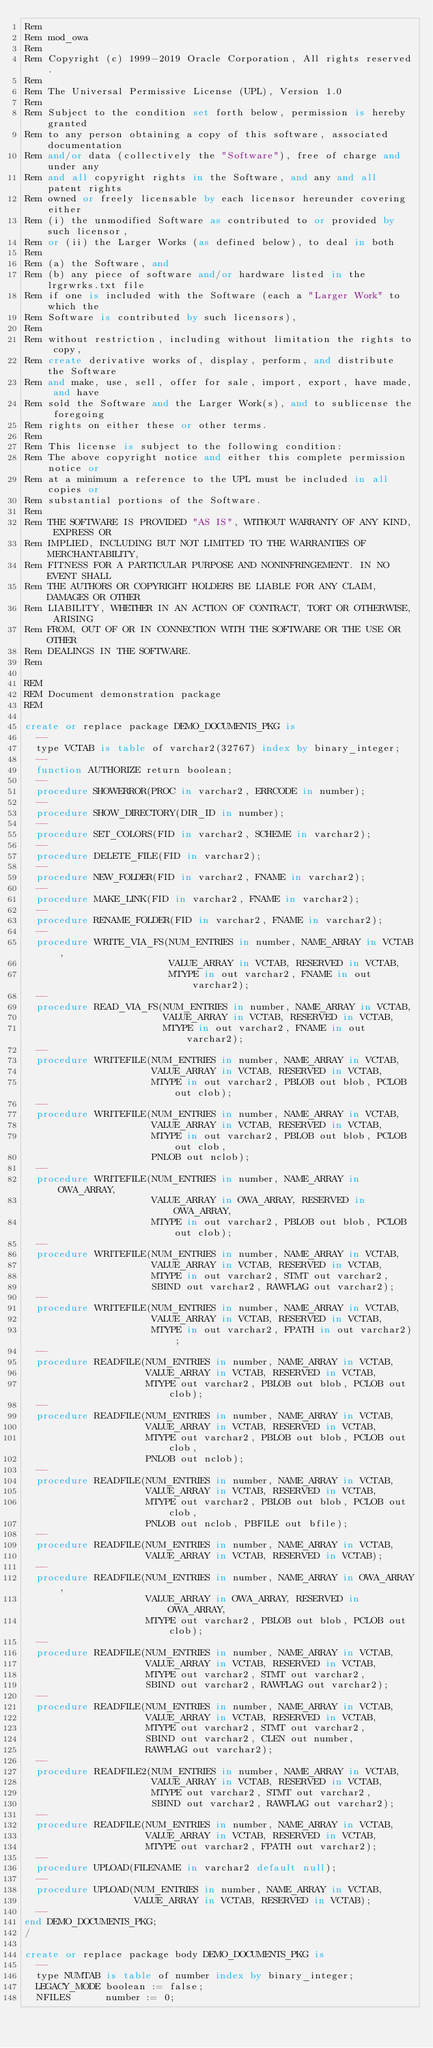Convert code to text. <code><loc_0><loc_0><loc_500><loc_500><_SQL_>Rem
Rem mod_owa
Rem
Rem Copyright (c) 1999-2019 Oracle Corporation, All rights reserved.
Rem
Rem The Universal Permissive License (UPL), Version 1.0
Rem
Rem Subject to the condition set forth below, permission is hereby granted
Rem to any person obtaining a copy of this software, associated documentation
Rem and/or data (collectively the "Software"), free of charge and under any
Rem and all copyright rights in the Software, and any and all patent rights
Rem owned or freely licensable by each licensor hereunder covering either
Rem (i) the unmodified Software as contributed to or provided by such licensor,
Rem or (ii) the Larger Works (as defined below), to deal in both
Rem 
Rem (a) the Software, and
Rem (b) any piece of software and/or hardware listed in the lrgrwrks.txt file
Rem if one is included with the Software (each a "Larger Work" to which the
Rem Software is contributed by such licensors),
Rem 
Rem without restriction, including without limitation the rights to copy,
Rem create derivative works of, display, perform, and distribute the Software
Rem and make, use, sell, offer for sale, import, export, have made, and have
Rem sold the Software and the Larger Work(s), and to sublicense the foregoing
Rem rights on either these or other terms.
Rem 
Rem This license is subject to the following condition:
Rem The above copyright notice and either this complete permission notice or
Rem at a minimum a reference to the UPL must be included in all copies or
Rem substantial portions of the Software.
Rem 
Rem THE SOFTWARE IS PROVIDED "AS IS", WITHOUT WARRANTY OF ANY KIND, EXPRESS OR
Rem IMPLIED, INCLUDING BUT NOT LIMITED TO THE WARRANTIES OF MERCHANTABILITY,
Rem FITNESS FOR A PARTICULAR PURPOSE AND NONINFRINGEMENT. IN NO EVENT SHALL
Rem THE AUTHORS OR COPYRIGHT HOLDERS BE LIABLE FOR ANY CLAIM, DAMAGES OR OTHER
Rem LIABILITY, WHETHER IN AN ACTION OF CONTRACT, TORT OR OTHERWISE, ARISING
Rem FROM, OUT OF OR IN CONNECTION WITH THE SOFTWARE OR THE USE OR OTHER
Rem DEALINGS IN THE SOFTWARE.
Rem

REM
REM Document demonstration package
REM

create or replace package DEMO_DOCUMENTS_PKG is
  --
  type VCTAB is table of varchar2(32767) index by binary_integer;
  --
  function AUTHORIZE return boolean;
  --
  procedure SHOWERROR(PROC in varchar2, ERRCODE in number);
  --
  procedure SHOW_DIRECTORY(DIR_ID in number);
  --
  procedure SET_COLORS(FID in varchar2, SCHEME in varchar2);
  --
  procedure DELETE_FILE(FID in varchar2);
  --
  procedure NEW_FOLDER(FID in varchar2, FNAME in varchar2);
  --
  procedure MAKE_LINK(FID in varchar2, FNAME in varchar2);
  --
  procedure RENAME_FOLDER(FID in varchar2, FNAME in varchar2);
  --
  procedure WRITE_VIA_FS(NUM_ENTRIES in number, NAME_ARRAY in VCTAB,
                         VALUE_ARRAY in VCTAB, RESERVED in VCTAB,
                         MTYPE in out varchar2, FNAME in out varchar2);
  --
  procedure READ_VIA_FS(NUM_ENTRIES in number, NAME_ARRAY in VCTAB,
                        VALUE_ARRAY in VCTAB, RESERVED in VCTAB,
                        MTYPE in out varchar2, FNAME in out varchar2);
  --
  procedure WRITEFILE(NUM_ENTRIES in number, NAME_ARRAY in VCTAB,
                      VALUE_ARRAY in VCTAB, RESERVED in VCTAB,
                      MTYPE in out varchar2, PBLOB out blob, PCLOB out clob);
  --
  procedure WRITEFILE(NUM_ENTRIES in number, NAME_ARRAY in VCTAB,
                      VALUE_ARRAY in VCTAB, RESERVED in VCTAB,
                      MTYPE in out varchar2, PBLOB out blob, PCLOB out clob,
                      PNLOB out nclob);
  --
  procedure WRITEFILE(NUM_ENTRIES in number, NAME_ARRAY in OWA_ARRAY,
                      VALUE_ARRAY in OWA_ARRAY, RESERVED in OWA_ARRAY,
                      MTYPE in out varchar2, PBLOB out blob, PCLOB out clob);
  --
  procedure WRITEFILE(NUM_ENTRIES in number, NAME_ARRAY in VCTAB,
                      VALUE_ARRAY in VCTAB, RESERVED in VCTAB,
                      MTYPE in out varchar2, STMT out varchar2,
                      SBIND out varchar2, RAWFLAG out varchar2);
  --
  procedure WRITEFILE(NUM_ENTRIES in number, NAME_ARRAY in VCTAB,
                      VALUE_ARRAY in VCTAB, RESERVED in VCTAB,
                      MTYPE in out varchar2, FPATH in out varchar2);
  --
  procedure READFILE(NUM_ENTRIES in number, NAME_ARRAY in VCTAB,
                     VALUE_ARRAY in VCTAB, RESERVED in VCTAB,
                     MTYPE out varchar2, PBLOB out blob, PCLOB out clob);
  --
  procedure READFILE(NUM_ENTRIES in number, NAME_ARRAY in VCTAB,
                     VALUE_ARRAY in VCTAB, RESERVED in VCTAB,
                     MTYPE out varchar2, PBLOB out blob, PCLOB out clob,
                     PNLOB out nclob);
  --
  procedure READFILE(NUM_ENTRIES in number, NAME_ARRAY in VCTAB,
                     VALUE_ARRAY in VCTAB, RESERVED in VCTAB,
                     MTYPE out varchar2, PBLOB out blob, PCLOB out clob,
                     PNLOB out nclob, PBFILE out bfile);
  --
  procedure READFILE(NUM_ENTRIES in number, NAME_ARRAY in VCTAB,
                     VALUE_ARRAY in VCTAB, RESERVED in VCTAB);
  --
  procedure READFILE(NUM_ENTRIES in number, NAME_ARRAY in OWA_ARRAY,
                     VALUE_ARRAY in OWA_ARRAY, RESERVED in OWA_ARRAY,
                     MTYPE out varchar2, PBLOB out blob, PCLOB out clob);
  --
  procedure READFILE(NUM_ENTRIES in number, NAME_ARRAY in VCTAB,
                     VALUE_ARRAY in VCTAB, RESERVED in VCTAB,
                     MTYPE out varchar2, STMT out varchar2,
                     SBIND out varchar2, RAWFLAG out varchar2);
  --
  procedure READFILE(NUM_ENTRIES in number, NAME_ARRAY in VCTAB,
                     VALUE_ARRAY in VCTAB, RESERVED in VCTAB,
                     MTYPE out varchar2, STMT out varchar2,
                     SBIND out varchar2, CLEN out number,
                     RAWFLAG out varchar2);
  --
  procedure READFILE2(NUM_ENTRIES in number, NAME_ARRAY in VCTAB,
                      VALUE_ARRAY in VCTAB, RESERVED in VCTAB,
                      MTYPE out varchar2, STMT out varchar2,
                      SBIND out varchar2, RAWFLAG out varchar2);
  --
  procedure READFILE(NUM_ENTRIES in number, NAME_ARRAY in VCTAB,
                     VALUE_ARRAY in VCTAB, RESERVED in VCTAB,
                     MTYPE out varchar2, FPATH out varchar2);
  --
  procedure UPLOAD(FILENAME in varchar2 default null);
  --
  procedure UPLOAD(NUM_ENTRIES in number, NAME_ARRAY in VCTAB,
                   VALUE_ARRAY in VCTAB, RESERVED in VCTAB);
  --
end DEMO_DOCUMENTS_PKG;
/

create or replace package body DEMO_DOCUMENTS_PKG is
  --
  type NUMTAB is table of number index by binary_integer;
  LEGACY_MODE boolean := false;
  NFILES      number := 0;</code> 